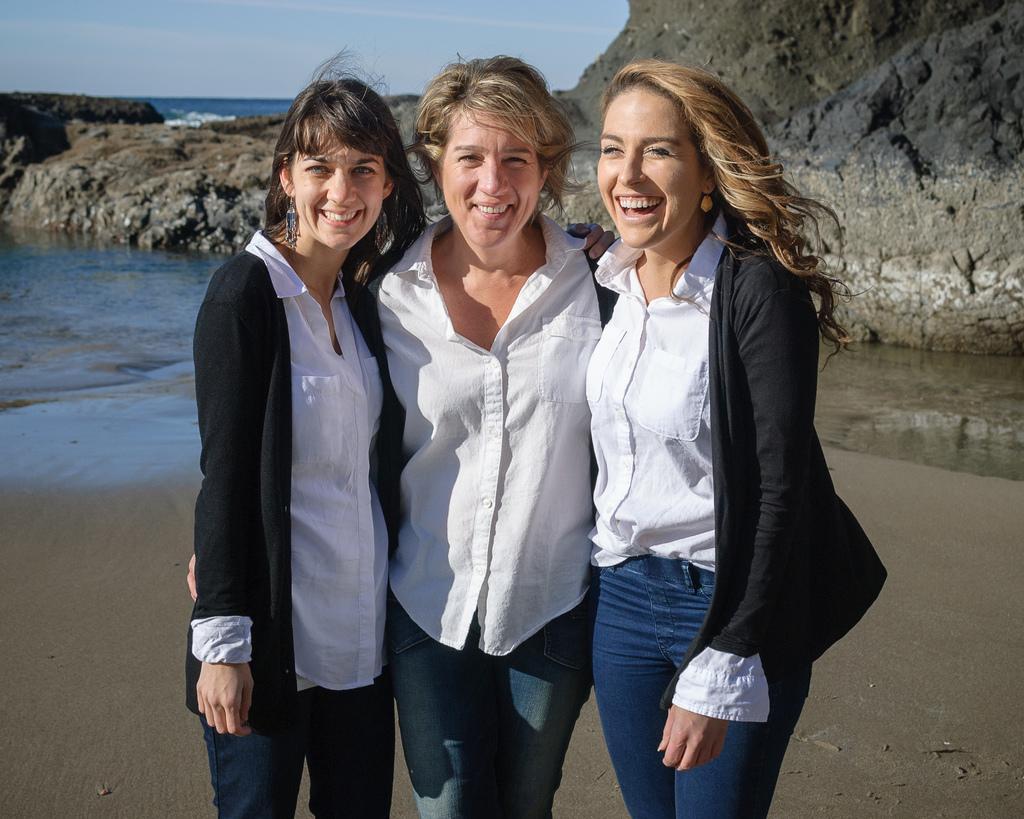Please provide a concise description of this image. Here we can see three women and they are smiling. In the background we can see water, rock, and sky. 